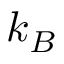<formula> <loc_0><loc_0><loc_500><loc_500>k _ { B }</formula> 